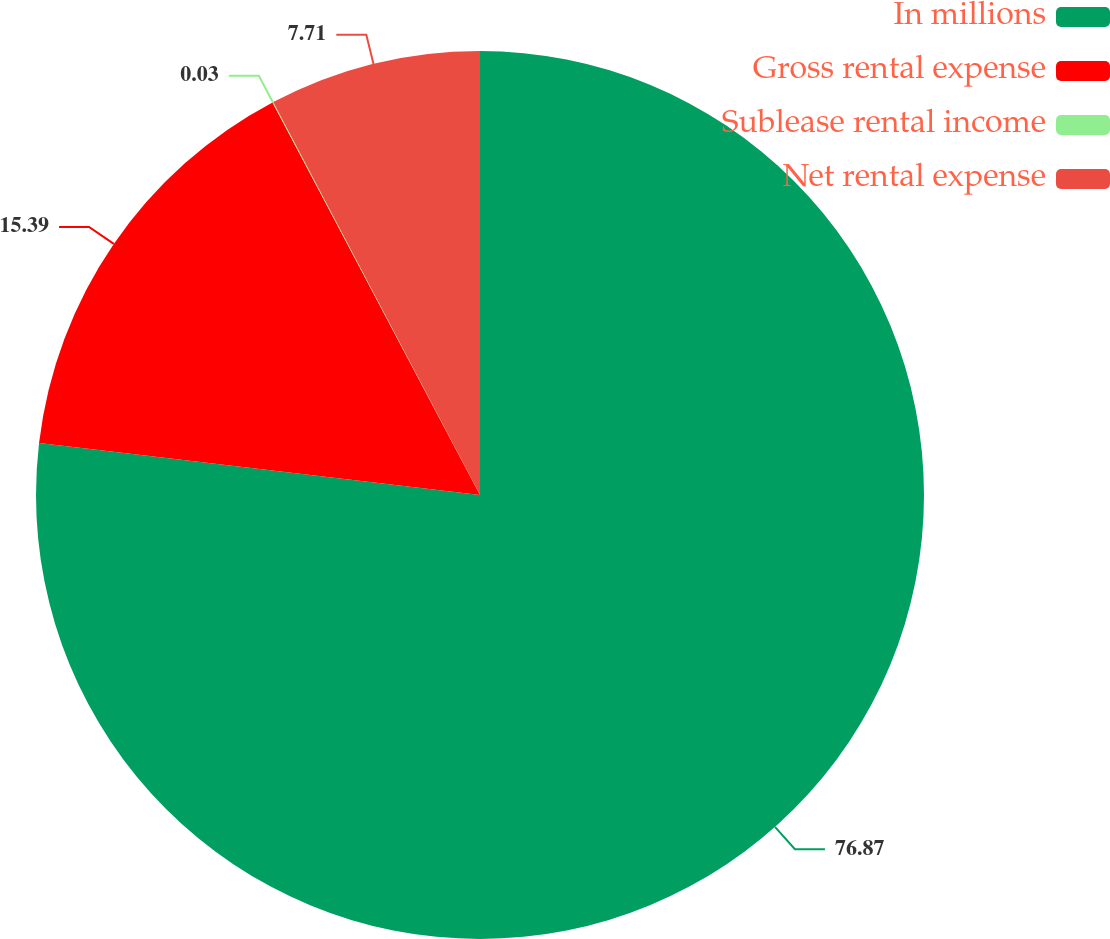<chart> <loc_0><loc_0><loc_500><loc_500><pie_chart><fcel>In millions<fcel>Gross rental expense<fcel>Sublease rental income<fcel>Net rental expense<nl><fcel>76.87%<fcel>15.39%<fcel>0.03%<fcel>7.71%<nl></chart> 